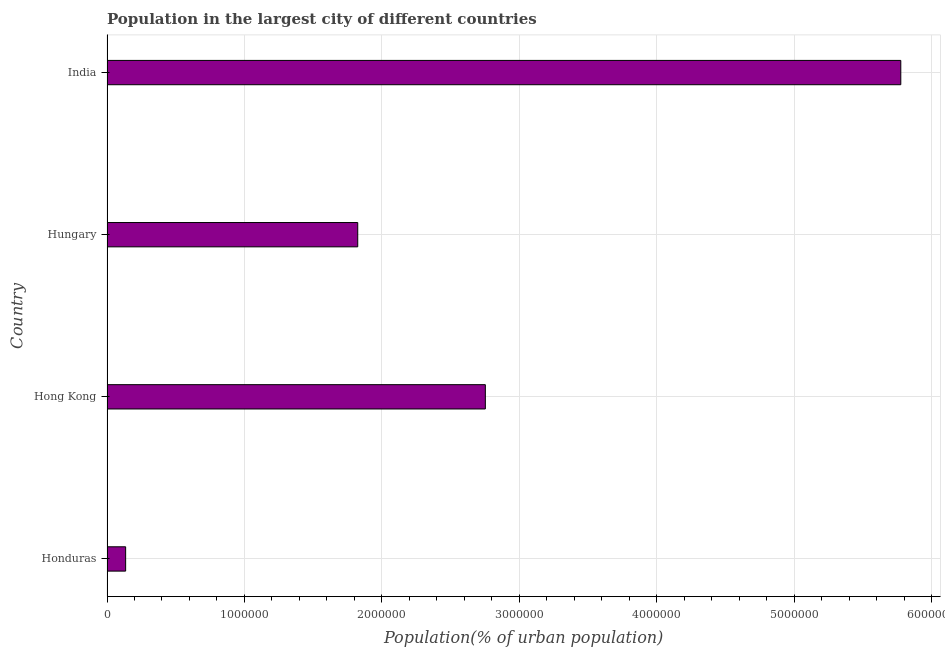Does the graph contain grids?
Provide a succinct answer. Yes. What is the title of the graph?
Provide a short and direct response. Population in the largest city of different countries. What is the label or title of the X-axis?
Your answer should be very brief. Population(% of urban population). What is the population in largest city in Hong Kong?
Your response must be concise. 2.75e+06. Across all countries, what is the maximum population in largest city?
Make the answer very short. 5.78e+06. Across all countries, what is the minimum population in largest city?
Offer a terse response. 1.36e+05. In which country was the population in largest city minimum?
Offer a very short reply. Honduras. What is the sum of the population in largest city?
Your answer should be very brief. 1.05e+07. What is the difference between the population in largest city in Hungary and India?
Your answer should be compact. -3.95e+06. What is the average population in largest city per country?
Give a very brief answer. 2.62e+06. What is the median population in largest city?
Ensure brevity in your answer.  2.29e+06. In how many countries, is the population in largest city greater than 2000000 %?
Offer a terse response. 2. What is the ratio of the population in largest city in Honduras to that in India?
Provide a succinct answer. 0.02. Is the population in largest city in Honduras less than that in India?
Offer a very short reply. Yes. What is the difference between the highest and the second highest population in largest city?
Your answer should be compact. 3.02e+06. Is the sum of the population in largest city in Hong Kong and India greater than the maximum population in largest city across all countries?
Your answer should be very brief. Yes. What is the difference between the highest and the lowest population in largest city?
Your response must be concise. 5.64e+06. In how many countries, is the population in largest city greater than the average population in largest city taken over all countries?
Your answer should be compact. 2. How many bars are there?
Keep it short and to the point. 4. Are all the bars in the graph horizontal?
Provide a short and direct response. Yes. How many countries are there in the graph?
Make the answer very short. 4. What is the difference between two consecutive major ticks on the X-axis?
Your answer should be very brief. 1.00e+06. Are the values on the major ticks of X-axis written in scientific E-notation?
Make the answer very short. No. What is the Population(% of urban population) of Honduras?
Give a very brief answer. 1.36e+05. What is the Population(% of urban population) in Hong Kong?
Your response must be concise. 2.75e+06. What is the Population(% of urban population) in Hungary?
Offer a very short reply. 1.82e+06. What is the Population(% of urban population) of India?
Give a very brief answer. 5.78e+06. What is the difference between the Population(% of urban population) in Honduras and Hong Kong?
Your response must be concise. -2.62e+06. What is the difference between the Population(% of urban population) in Honduras and Hungary?
Provide a short and direct response. -1.69e+06. What is the difference between the Population(% of urban population) in Honduras and India?
Give a very brief answer. -5.64e+06. What is the difference between the Population(% of urban population) in Hong Kong and Hungary?
Make the answer very short. 9.28e+05. What is the difference between the Population(% of urban population) in Hong Kong and India?
Your answer should be very brief. -3.02e+06. What is the difference between the Population(% of urban population) in Hungary and India?
Your answer should be very brief. -3.95e+06. What is the ratio of the Population(% of urban population) in Honduras to that in Hong Kong?
Provide a succinct answer. 0.05. What is the ratio of the Population(% of urban population) in Honduras to that in Hungary?
Your answer should be compact. 0.07. What is the ratio of the Population(% of urban population) in Honduras to that in India?
Your answer should be very brief. 0.02. What is the ratio of the Population(% of urban population) in Hong Kong to that in Hungary?
Ensure brevity in your answer.  1.51. What is the ratio of the Population(% of urban population) in Hong Kong to that in India?
Offer a terse response. 0.48. What is the ratio of the Population(% of urban population) in Hungary to that in India?
Keep it short and to the point. 0.32. 